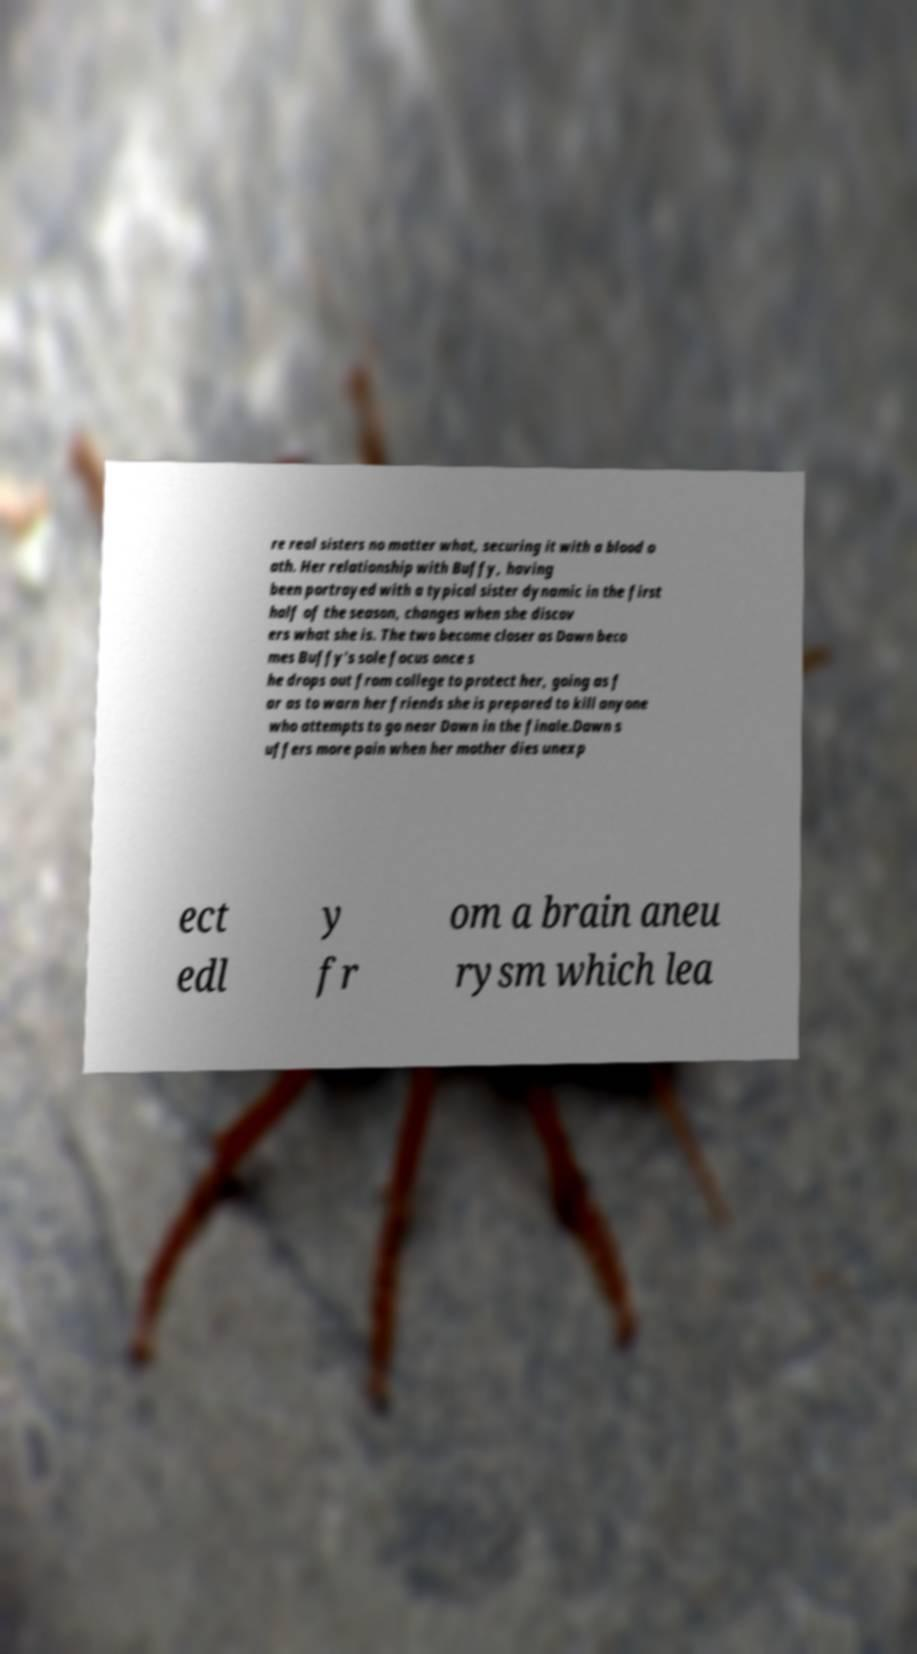There's text embedded in this image that I need extracted. Can you transcribe it verbatim? re real sisters no matter what, securing it with a blood o ath. Her relationship with Buffy, having been portrayed with a typical sister dynamic in the first half of the season, changes when she discov ers what she is. The two become closer as Dawn beco mes Buffy's sole focus once s he drops out from college to protect her, going as f ar as to warn her friends she is prepared to kill anyone who attempts to go near Dawn in the finale.Dawn s uffers more pain when her mother dies unexp ect edl y fr om a brain aneu rysm which lea 